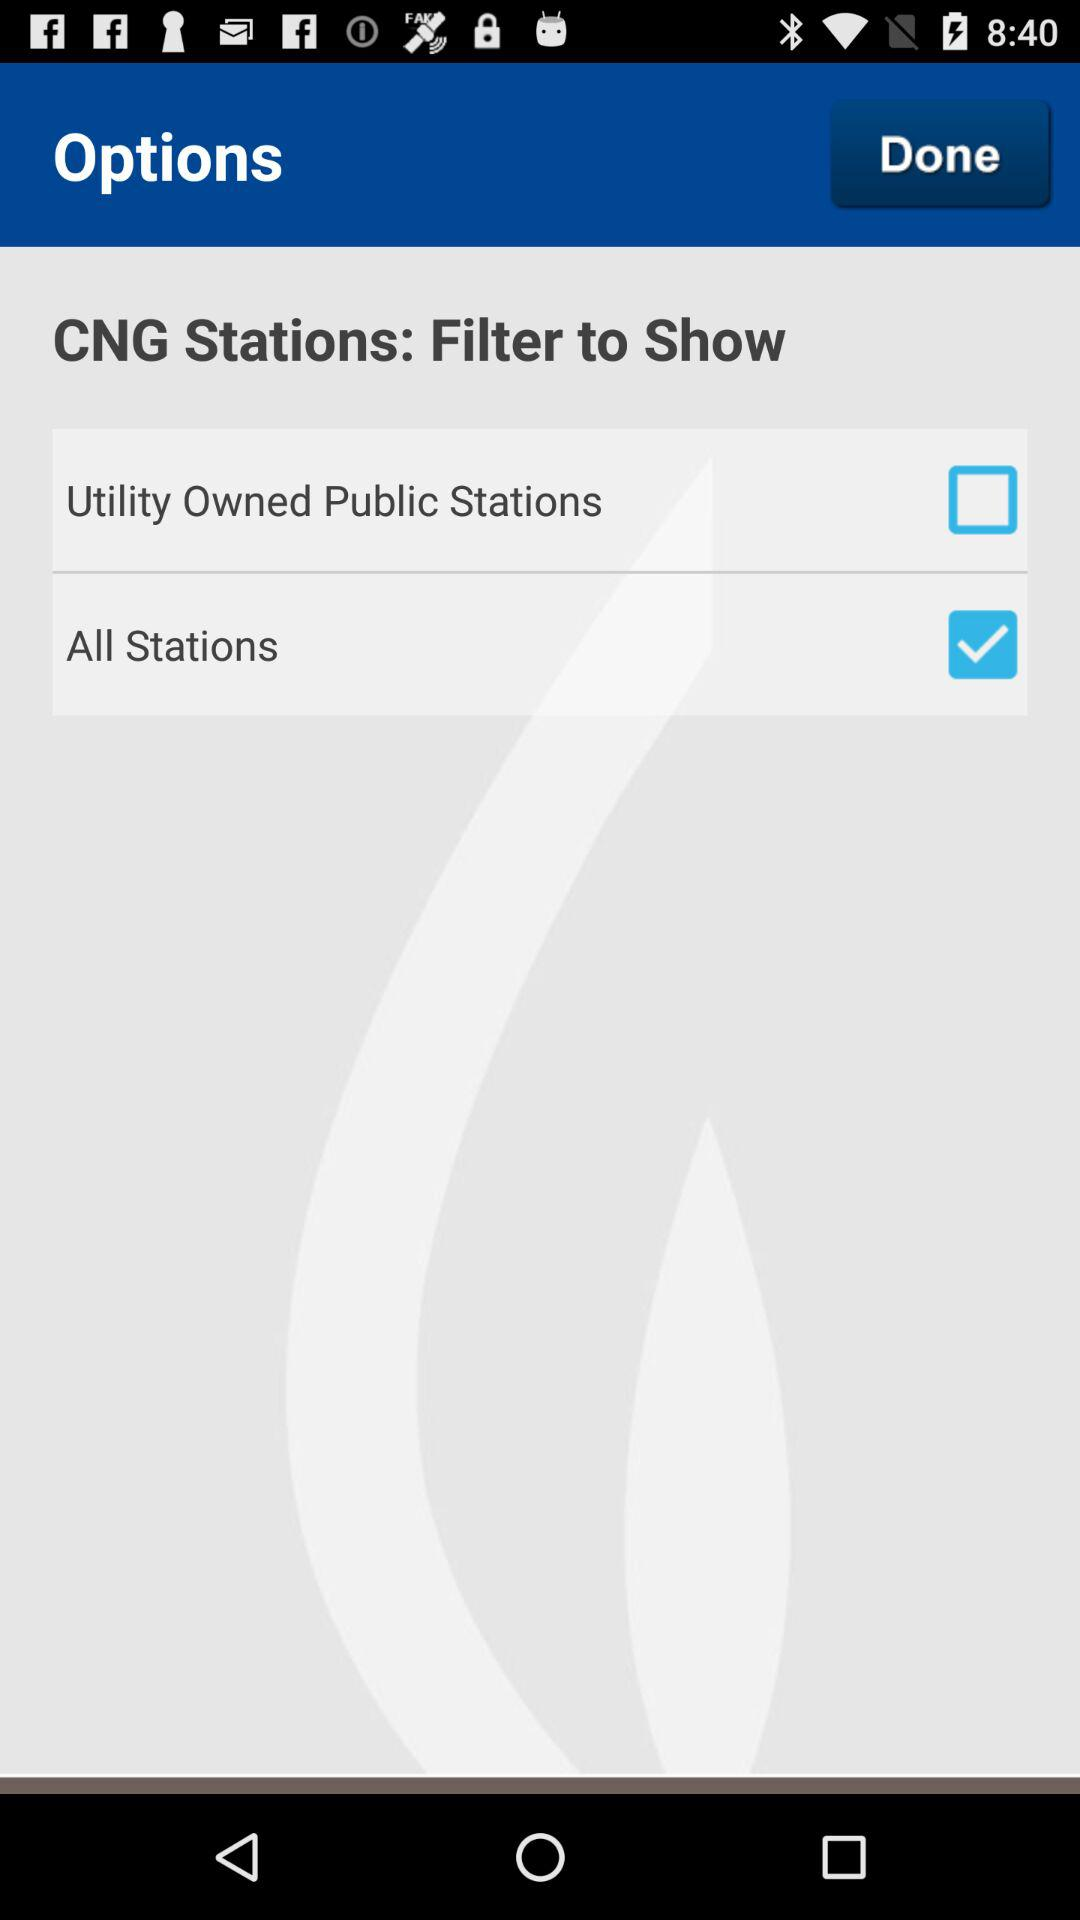What is the status of "Utility Owned Public Stations"? The status is "off". 